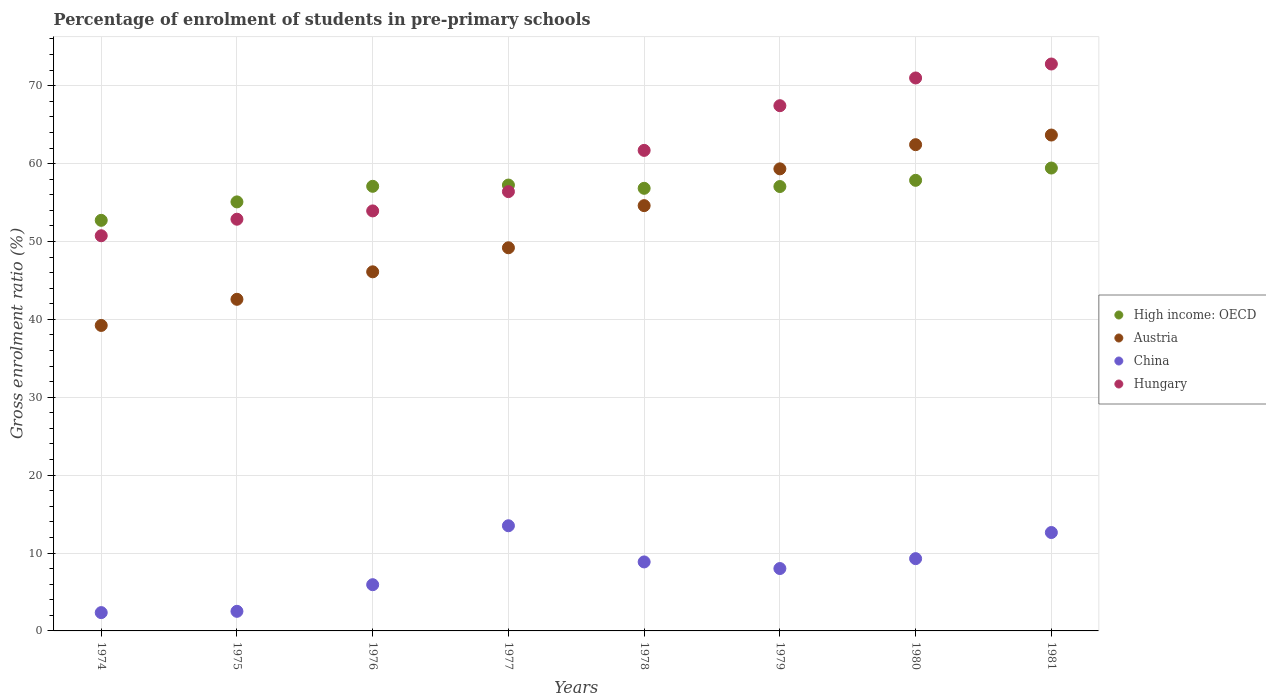How many different coloured dotlines are there?
Give a very brief answer. 4. What is the percentage of students enrolled in pre-primary schools in High income: OECD in 1974?
Offer a terse response. 52.72. Across all years, what is the maximum percentage of students enrolled in pre-primary schools in China?
Your response must be concise. 13.5. Across all years, what is the minimum percentage of students enrolled in pre-primary schools in China?
Keep it short and to the point. 2.35. In which year was the percentage of students enrolled in pre-primary schools in High income: OECD minimum?
Your response must be concise. 1974. What is the total percentage of students enrolled in pre-primary schools in High income: OECD in the graph?
Your answer should be compact. 453.31. What is the difference between the percentage of students enrolled in pre-primary schools in High income: OECD in 1977 and that in 1980?
Ensure brevity in your answer.  -0.61. What is the difference between the percentage of students enrolled in pre-primary schools in High income: OECD in 1976 and the percentage of students enrolled in pre-primary schools in Austria in 1974?
Provide a short and direct response. 17.86. What is the average percentage of students enrolled in pre-primary schools in Austria per year?
Offer a very short reply. 52.14. In the year 1978, what is the difference between the percentage of students enrolled in pre-primary schools in Hungary and percentage of students enrolled in pre-primary schools in High income: OECD?
Ensure brevity in your answer.  4.87. In how many years, is the percentage of students enrolled in pre-primary schools in Hungary greater than 26 %?
Provide a succinct answer. 8. What is the ratio of the percentage of students enrolled in pre-primary schools in Austria in 1976 to that in 1980?
Your answer should be very brief. 0.74. Is the percentage of students enrolled in pre-primary schools in Hungary in 1975 less than that in 1980?
Your answer should be compact. Yes. Is the difference between the percentage of students enrolled in pre-primary schools in Hungary in 1980 and 1981 greater than the difference between the percentage of students enrolled in pre-primary schools in High income: OECD in 1980 and 1981?
Your answer should be very brief. No. What is the difference between the highest and the second highest percentage of students enrolled in pre-primary schools in Austria?
Your answer should be very brief. 1.24. What is the difference between the highest and the lowest percentage of students enrolled in pre-primary schools in China?
Provide a short and direct response. 11.15. In how many years, is the percentage of students enrolled in pre-primary schools in Hungary greater than the average percentage of students enrolled in pre-primary schools in Hungary taken over all years?
Offer a terse response. 4. Does the percentage of students enrolled in pre-primary schools in China monotonically increase over the years?
Your answer should be very brief. No. Is the percentage of students enrolled in pre-primary schools in High income: OECD strictly greater than the percentage of students enrolled in pre-primary schools in Hungary over the years?
Provide a short and direct response. No. Is the percentage of students enrolled in pre-primary schools in China strictly less than the percentage of students enrolled in pre-primary schools in High income: OECD over the years?
Provide a short and direct response. Yes. How many years are there in the graph?
Provide a short and direct response. 8. Are the values on the major ticks of Y-axis written in scientific E-notation?
Make the answer very short. No. Does the graph contain grids?
Provide a short and direct response. Yes. What is the title of the graph?
Your answer should be compact. Percentage of enrolment of students in pre-primary schools. What is the Gross enrolment ratio (%) of High income: OECD in 1974?
Your answer should be compact. 52.72. What is the Gross enrolment ratio (%) in Austria in 1974?
Offer a terse response. 39.22. What is the Gross enrolment ratio (%) of China in 1974?
Keep it short and to the point. 2.35. What is the Gross enrolment ratio (%) in Hungary in 1974?
Offer a very short reply. 50.74. What is the Gross enrolment ratio (%) in High income: OECD in 1975?
Your response must be concise. 55.08. What is the Gross enrolment ratio (%) of Austria in 1975?
Your answer should be compact. 42.58. What is the Gross enrolment ratio (%) in China in 1975?
Ensure brevity in your answer.  2.52. What is the Gross enrolment ratio (%) of Hungary in 1975?
Give a very brief answer. 52.86. What is the Gross enrolment ratio (%) of High income: OECD in 1976?
Your response must be concise. 57.09. What is the Gross enrolment ratio (%) of Austria in 1976?
Offer a very short reply. 46.11. What is the Gross enrolment ratio (%) of China in 1976?
Your answer should be compact. 5.93. What is the Gross enrolment ratio (%) of Hungary in 1976?
Your response must be concise. 53.93. What is the Gross enrolment ratio (%) of High income: OECD in 1977?
Provide a succinct answer. 57.25. What is the Gross enrolment ratio (%) in Austria in 1977?
Your answer should be compact. 49.19. What is the Gross enrolment ratio (%) in China in 1977?
Provide a short and direct response. 13.5. What is the Gross enrolment ratio (%) in Hungary in 1977?
Keep it short and to the point. 56.4. What is the Gross enrolment ratio (%) in High income: OECD in 1978?
Give a very brief answer. 56.83. What is the Gross enrolment ratio (%) in Austria in 1978?
Provide a short and direct response. 54.6. What is the Gross enrolment ratio (%) in China in 1978?
Offer a terse response. 8.86. What is the Gross enrolment ratio (%) of Hungary in 1978?
Provide a succinct answer. 61.7. What is the Gross enrolment ratio (%) in High income: OECD in 1979?
Keep it short and to the point. 57.06. What is the Gross enrolment ratio (%) of Austria in 1979?
Provide a succinct answer. 59.33. What is the Gross enrolment ratio (%) in China in 1979?
Ensure brevity in your answer.  8.01. What is the Gross enrolment ratio (%) in Hungary in 1979?
Provide a succinct answer. 67.44. What is the Gross enrolment ratio (%) in High income: OECD in 1980?
Give a very brief answer. 57.85. What is the Gross enrolment ratio (%) in Austria in 1980?
Keep it short and to the point. 62.43. What is the Gross enrolment ratio (%) in China in 1980?
Offer a terse response. 9.28. What is the Gross enrolment ratio (%) of Hungary in 1980?
Provide a short and direct response. 71. What is the Gross enrolment ratio (%) in High income: OECD in 1981?
Offer a very short reply. 59.43. What is the Gross enrolment ratio (%) in Austria in 1981?
Provide a succinct answer. 63.67. What is the Gross enrolment ratio (%) in China in 1981?
Give a very brief answer. 12.63. What is the Gross enrolment ratio (%) in Hungary in 1981?
Offer a terse response. 72.79. Across all years, what is the maximum Gross enrolment ratio (%) in High income: OECD?
Keep it short and to the point. 59.43. Across all years, what is the maximum Gross enrolment ratio (%) of Austria?
Offer a terse response. 63.67. Across all years, what is the maximum Gross enrolment ratio (%) of China?
Ensure brevity in your answer.  13.5. Across all years, what is the maximum Gross enrolment ratio (%) of Hungary?
Ensure brevity in your answer.  72.79. Across all years, what is the minimum Gross enrolment ratio (%) of High income: OECD?
Your answer should be very brief. 52.72. Across all years, what is the minimum Gross enrolment ratio (%) of Austria?
Keep it short and to the point. 39.22. Across all years, what is the minimum Gross enrolment ratio (%) of China?
Offer a very short reply. 2.35. Across all years, what is the minimum Gross enrolment ratio (%) of Hungary?
Your response must be concise. 50.74. What is the total Gross enrolment ratio (%) of High income: OECD in the graph?
Give a very brief answer. 453.31. What is the total Gross enrolment ratio (%) in Austria in the graph?
Offer a very short reply. 417.13. What is the total Gross enrolment ratio (%) in China in the graph?
Keep it short and to the point. 63.09. What is the total Gross enrolment ratio (%) of Hungary in the graph?
Give a very brief answer. 486.85. What is the difference between the Gross enrolment ratio (%) in High income: OECD in 1974 and that in 1975?
Your answer should be very brief. -2.37. What is the difference between the Gross enrolment ratio (%) of Austria in 1974 and that in 1975?
Your response must be concise. -3.36. What is the difference between the Gross enrolment ratio (%) in China in 1974 and that in 1975?
Your answer should be very brief. -0.17. What is the difference between the Gross enrolment ratio (%) in Hungary in 1974 and that in 1975?
Give a very brief answer. -2.12. What is the difference between the Gross enrolment ratio (%) of High income: OECD in 1974 and that in 1976?
Your response must be concise. -4.37. What is the difference between the Gross enrolment ratio (%) in Austria in 1974 and that in 1976?
Your response must be concise. -6.88. What is the difference between the Gross enrolment ratio (%) of China in 1974 and that in 1976?
Offer a terse response. -3.58. What is the difference between the Gross enrolment ratio (%) in Hungary in 1974 and that in 1976?
Your answer should be compact. -3.19. What is the difference between the Gross enrolment ratio (%) in High income: OECD in 1974 and that in 1977?
Make the answer very short. -4.53. What is the difference between the Gross enrolment ratio (%) of Austria in 1974 and that in 1977?
Your answer should be compact. -9.97. What is the difference between the Gross enrolment ratio (%) in China in 1974 and that in 1977?
Keep it short and to the point. -11.15. What is the difference between the Gross enrolment ratio (%) of Hungary in 1974 and that in 1977?
Offer a very short reply. -5.67. What is the difference between the Gross enrolment ratio (%) in High income: OECD in 1974 and that in 1978?
Your answer should be very brief. -4.11. What is the difference between the Gross enrolment ratio (%) of Austria in 1974 and that in 1978?
Your response must be concise. -15.38. What is the difference between the Gross enrolment ratio (%) in China in 1974 and that in 1978?
Keep it short and to the point. -6.51. What is the difference between the Gross enrolment ratio (%) of Hungary in 1974 and that in 1978?
Ensure brevity in your answer.  -10.96. What is the difference between the Gross enrolment ratio (%) in High income: OECD in 1974 and that in 1979?
Provide a short and direct response. -4.34. What is the difference between the Gross enrolment ratio (%) of Austria in 1974 and that in 1979?
Offer a terse response. -20.1. What is the difference between the Gross enrolment ratio (%) in China in 1974 and that in 1979?
Give a very brief answer. -5.66. What is the difference between the Gross enrolment ratio (%) in Hungary in 1974 and that in 1979?
Provide a short and direct response. -16.7. What is the difference between the Gross enrolment ratio (%) of High income: OECD in 1974 and that in 1980?
Offer a very short reply. -5.14. What is the difference between the Gross enrolment ratio (%) of Austria in 1974 and that in 1980?
Your answer should be compact. -23.21. What is the difference between the Gross enrolment ratio (%) of China in 1974 and that in 1980?
Offer a very short reply. -6.93. What is the difference between the Gross enrolment ratio (%) in Hungary in 1974 and that in 1980?
Provide a succinct answer. -20.26. What is the difference between the Gross enrolment ratio (%) in High income: OECD in 1974 and that in 1981?
Offer a very short reply. -6.72. What is the difference between the Gross enrolment ratio (%) in Austria in 1974 and that in 1981?
Your response must be concise. -24.45. What is the difference between the Gross enrolment ratio (%) of China in 1974 and that in 1981?
Offer a terse response. -10.28. What is the difference between the Gross enrolment ratio (%) in Hungary in 1974 and that in 1981?
Give a very brief answer. -22.05. What is the difference between the Gross enrolment ratio (%) in High income: OECD in 1975 and that in 1976?
Ensure brevity in your answer.  -2. What is the difference between the Gross enrolment ratio (%) in Austria in 1975 and that in 1976?
Give a very brief answer. -3.53. What is the difference between the Gross enrolment ratio (%) in China in 1975 and that in 1976?
Provide a succinct answer. -3.42. What is the difference between the Gross enrolment ratio (%) of Hungary in 1975 and that in 1976?
Give a very brief answer. -1.06. What is the difference between the Gross enrolment ratio (%) of High income: OECD in 1975 and that in 1977?
Make the answer very short. -2.16. What is the difference between the Gross enrolment ratio (%) in Austria in 1975 and that in 1977?
Your answer should be compact. -6.62. What is the difference between the Gross enrolment ratio (%) of China in 1975 and that in 1977?
Keep it short and to the point. -10.99. What is the difference between the Gross enrolment ratio (%) in Hungary in 1975 and that in 1977?
Provide a short and direct response. -3.54. What is the difference between the Gross enrolment ratio (%) in High income: OECD in 1975 and that in 1978?
Your response must be concise. -1.74. What is the difference between the Gross enrolment ratio (%) of Austria in 1975 and that in 1978?
Give a very brief answer. -12.03. What is the difference between the Gross enrolment ratio (%) of China in 1975 and that in 1978?
Offer a very short reply. -6.34. What is the difference between the Gross enrolment ratio (%) in Hungary in 1975 and that in 1978?
Offer a terse response. -8.84. What is the difference between the Gross enrolment ratio (%) of High income: OECD in 1975 and that in 1979?
Offer a terse response. -1.97. What is the difference between the Gross enrolment ratio (%) of Austria in 1975 and that in 1979?
Provide a short and direct response. -16.75. What is the difference between the Gross enrolment ratio (%) in China in 1975 and that in 1979?
Keep it short and to the point. -5.49. What is the difference between the Gross enrolment ratio (%) of Hungary in 1975 and that in 1979?
Ensure brevity in your answer.  -14.57. What is the difference between the Gross enrolment ratio (%) in High income: OECD in 1975 and that in 1980?
Offer a terse response. -2.77. What is the difference between the Gross enrolment ratio (%) of Austria in 1975 and that in 1980?
Give a very brief answer. -19.85. What is the difference between the Gross enrolment ratio (%) in China in 1975 and that in 1980?
Make the answer very short. -6.76. What is the difference between the Gross enrolment ratio (%) in Hungary in 1975 and that in 1980?
Offer a terse response. -18.13. What is the difference between the Gross enrolment ratio (%) in High income: OECD in 1975 and that in 1981?
Offer a terse response. -4.35. What is the difference between the Gross enrolment ratio (%) of Austria in 1975 and that in 1981?
Ensure brevity in your answer.  -21.09. What is the difference between the Gross enrolment ratio (%) of China in 1975 and that in 1981?
Give a very brief answer. -10.12. What is the difference between the Gross enrolment ratio (%) in Hungary in 1975 and that in 1981?
Your answer should be compact. -19.93. What is the difference between the Gross enrolment ratio (%) of High income: OECD in 1976 and that in 1977?
Give a very brief answer. -0.16. What is the difference between the Gross enrolment ratio (%) of Austria in 1976 and that in 1977?
Your answer should be compact. -3.09. What is the difference between the Gross enrolment ratio (%) in China in 1976 and that in 1977?
Offer a very short reply. -7.57. What is the difference between the Gross enrolment ratio (%) in Hungary in 1976 and that in 1977?
Your answer should be very brief. -2.48. What is the difference between the Gross enrolment ratio (%) in High income: OECD in 1976 and that in 1978?
Provide a short and direct response. 0.26. What is the difference between the Gross enrolment ratio (%) in Austria in 1976 and that in 1978?
Ensure brevity in your answer.  -8.5. What is the difference between the Gross enrolment ratio (%) in China in 1976 and that in 1978?
Your answer should be very brief. -2.92. What is the difference between the Gross enrolment ratio (%) of Hungary in 1976 and that in 1978?
Make the answer very short. -7.77. What is the difference between the Gross enrolment ratio (%) of High income: OECD in 1976 and that in 1979?
Your response must be concise. 0.03. What is the difference between the Gross enrolment ratio (%) of Austria in 1976 and that in 1979?
Offer a very short reply. -13.22. What is the difference between the Gross enrolment ratio (%) of China in 1976 and that in 1979?
Offer a very short reply. -2.08. What is the difference between the Gross enrolment ratio (%) in Hungary in 1976 and that in 1979?
Offer a terse response. -13.51. What is the difference between the Gross enrolment ratio (%) in High income: OECD in 1976 and that in 1980?
Your response must be concise. -0.77. What is the difference between the Gross enrolment ratio (%) in Austria in 1976 and that in 1980?
Provide a short and direct response. -16.32. What is the difference between the Gross enrolment ratio (%) in China in 1976 and that in 1980?
Keep it short and to the point. -3.35. What is the difference between the Gross enrolment ratio (%) of Hungary in 1976 and that in 1980?
Provide a short and direct response. -17.07. What is the difference between the Gross enrolment ratio (%) in High income: OECD in 1976 and that in 1981?
Keep it short and to the point. -2.35. What is the difference between the Gross enrolment ratio (%) of Austria in 1976 and that in 1981?
Offer a terse response. -17.56. What is the difference between the Gross enrolment ratio (%) of Hungary in 1976 and that in 1981?
Make the answer very short. -18.86. What is the difference between the Gross enrolment ratio (%) in High income: OECD in 1977 and that in 1978?
Provide a short and direct response. 0.42. What is the difference between the Gross enrolment ratio (%) of Austria in 1977 and that in 1978?
Provide a succinct answer. -5.41. What is the difference between the Gross enrolment ratio (%) of China in 1977 and that in 1978?
Keep it short and to the point. 4.64. What is the difference between the Gross enrolment ratio (%) of Hungary in 1977 and that in 1978?
Offer a terse response. -5.29. What is the difference between the Gross enrolment ratio (%) in High income: OECD in 1977 and that in 1979?
Your answer should be very brief. 0.19. What is the difference between the Gross enrolment ratio (%) in Austria in 1977 and that in 1979?
Give a very brief answer. -10.13. What is the difference between the Gross enrolment ratio (%) of China in 1977 and that in 1979?
Offer a very short reply. 5.49. What is the difference between the Gross enrolment ratio (%) in Hungary in 1977 and that in 1979?
Offer a very short reply. -11.03. What is the difference between the Gross enrolment ratio (%) of High income: OECD in 1977 and that in 1980?
Keep it short and to the point. -0.61. What is the difference between the Gross enrolment ratio (%) in Austria in 1977 and that in 1980?
Provide a short and direct response. -13.24. What is the difference between the Gross enrolment ratio (%) in China in 1977 and that in 1980?
Provide a short and direct response. 4.22. What is the difference between the Gross enrolment ratio (%) of Hungary in 1977 and that in 1980?
Make the answer very short. -14.59. What is the difference between the Gross enrolment ratio (%) of High income: OECD in 1977 and that in 1981?
Ensure brevity in your answer.  -2.19. What is the difference between the Gross enrolment ratio (%) of Austria in 1977 and that in 1981?
Offer a terse response. -14.47. What is the difference between the Gross enrolment ratio (%) of China in 1977 and that in 1981?
Provide a succinct answer. 0.87. What is the difference between the Gross enrolment ratio (%) in Hungary in 1977 and that in 1981?
Give a very brief answer. -16.38. What is the difference between the Gross enrolment ratio (%) of High income: OECD in 1978 and that in 1979?
Make the answer very short. -0.23. What is the difference between the Gross enrolment ratio (%) in Austria in 1978 and that in 1979?
Make the answer very short. -4.72. What is the difference between the Gross enrolment ratio (%) of China in 1978 and that in 1979?
Provide a short and direct response. 0.85. What is the difference between the Gross enrolment ratio (%) in Hungary in 1978 and that in 1979?
Provide a short and direct response. -5.74. What is the difference between the Gross enrolment ratio (%) in High income: OECD in 1978 and that in 1980?
Your answer should be compact. -1.03. What is the difference between the Gross enrolment ratio (%) in Austria in 1978 and that in 1980?
Provide a succinct answer. -7.83. What is the difference between the Gross enrolment ratio (%) of China in 1978 and that in 1980?
Provide a short and direct response. -0.42. What is the difference between the Gross enrolment ratio (%) in Hungary in 1978 and that in 1980?
Provide a succinct answer. -9.3. What is the difference between the Gross enrolment ratio (%) of High income: OECD in 1978 and that in 1981?
Your answer should be very brief. -2.6. What is the difference between the Gross enrolment ratio (%) in Austria in 1978 and that in 1981?
Make the answer very short. -9.06. What is the difference between the Gross enrolment ratio (%) of China in 1978 and that in 1981?
Make the answer very short. -3.78. What is the difference between the Gross enrolment ratio (%) of Hungary in 1978 and that in 1981?
Ensure brevity in your answer.  -11.09. What is the difference between the Gross enrolment ratio (%) of High income: OECD in 1979 and that in 1980?
Offer a very short reply. -0.8. What is the difference between the Gross enrolment ratio (%) in Austria in 1979 and that in 1980?
Your answer should be very brief. -3.1. What is the difference between the Gross enrolment ratio (%) in China in 1979 and that in 1980?
Offer a very short reply. -1.27. What is the difference between the Gross enrolment ratio (%) of Hungary in 1979 and that in 1980?
Make the answer very short. -3.56. What is the difference between the Gross enrolment ratio (%) of High income: OECD in 1979 and that in 1981?
Provide a succinct answer. -2.37. What is the difference between the Gross enrolment ratio (%) in Austria in 1979 and that in 1981?
Your answer should be very brief. -4.34. What is the difference between the Gross enrolment ratio (%) of China in 1979 and that in 1981?
Make the answer very short. -4.62. What is the difference between the Gross enrolment ratio (%) of Hungary in 1979 and that in 1981?
Your answer should be compact. -5.35. What is the difference between the Gross enrolment ratio (%) in High income: OECD in 1980 and that in 1981?
Keep it short and to the point. -1.58. What is the difference between the Gross enrolment ratio (%) in Austria in 1980 and that in 1981?
Your response must be concise. -1.24. What is the difference between the Gross enrolment ratio (%) in China in 1980 and that in 1981?
Offer a very short reply. -3.35. What is the difference between the Gross enrolment ratio (%) in Hungary in 1980 and that in 1981?
Make the answer very short. -1.79. What is the difference between the Gross enrolment ratio (%) in High income: OECD in 1974 and the Gross enrolment ratio (%) in Austria in 1975?
Offer a very short reply. 10.14. What is the difference between the Gross enrolment ratio (%) in High income: OECD in 1974 and the Gross enrolment ratio (%) in China in 1975?
Your answer should be compact. 50.2. What is the difference between the Gross enrolment ratio (%) of High income: OECD in 1974 and the Gross enrolment ratio (%) of Hungary in 1975?
Ensure brevity in your answer.  -0.14. What is the difference between the Gross enrolment ratio (%) in Austria in 1974 and the Gross enrolment ratio (%) in China in 1975?
Your response must be concise. 36.71. What is the difference between the Gross enrolment ratio (%) in Austria in 1974 and the Gross enrolment ratio (%) in Hungary in 1975?
Give a very brief answer. -13.64. What is the difference between the Gross enrolment ratio (%) in China in 1974 and the Gross enrolment ratio (%) in Hungary in 1975?
Provide a succinct answer. -50.51. What is the difference between the Gross enrolment ratio (%) of High income: OECD in 1974 and the Gross enrolment ratio (%) of Austria in 1976?
Make the answer very short. 6.61. What is the difference between the Gross enrolment ratio (%) of High income: OECD in 1974 and the Gross enrolment ratio (%) of China in 1976?
Ensure brevity in your answer.  46.78. What is the difference between the Gross enrolment ratio (%) in High income: OECD in 1974 and the Gross enrolment ratio (%) in Hungary in 1976?
Offer a very short reply. -1.21. What is the difference between the Gross enrolment ratio (%) in Austria in 1974 and the Gross enrolment ratio (%) in China in 1976?
Your answer should be very brief. 33.29. What is the difference between the Gross enrolment ratio (%) in Austria in 1974 and the Gross enrolment ratio (%) in Hungary in 1976?
Make the answer very short. -14.7. What is the difference between the Gross enrolment ratio (%) in China in 1974 and the Gross enrolment ratio (%) in Hungary in 1976?
Your response must be concise. -51.57. What is the difference between the Gross enrolment ratio (%) of High income: OECD in 1974 and the Gross enrolment ratio (%) of Austria in 1977?
Provide a succinct answer. 3.52. What is the difference between the Gross enrolment ratio (%) of High income: OECD in 1974 and the Gross enrolment ratio (%) of China in 1977?
Your answer should be very brief. 39.21. What is the difference between the Gross enrolment ratio (%) in High income: OECD in 1974 and the Gross enrolment ratio (%) in Hungary in 1977?
Ensure brevity in your answer.  -3.69. What is the difference between the Gross enrolment ratio (%) of Austria in 1974 and the Gross enrolment ratio (%) of China in 1977?
Your answer should be compact. 25.72. What is the difference between the Gross enrolment ratio (%) of Austria in 1974 and the Gross enrolment ratio (%) of Hungary in 1977?
Give a very brief answer. -17.18. What is the difference between the Gross enrolment ratio (%) in China in 1974 and the Gross enrolment ratio (%) in Hungary in 1977?
Provide a succinct answer. -54.05. What is the difference between the Gross enrolment ratio (%) in High income: OECD in 1974 and the Gross enrolment ratio (%) in Austria in 1978?
Keep it short and to the point. -1.89. What is the difference between the Gross enrolment ratio (%) of High income: OECD in 1974 and the Gross enrolment ratio (%) of China in 1978?
Your response must be concise. 43.86. What is the difference between the Gross enrolment ratio (%) in High income: OECD in 1974 and the Gross enrolment ratio (%) in Hungary in 1978?
Provide a succinct answer. -8.98. What is the difference between the Gross enrolment ratio (%) of Austria in 1974 and the Gross enrolment ratio (%) of China in 1978?
Offer a very short reply. 30.36. What is the difference between the Gross enrolment ratio (%) in Austria in 1974 and the Gross enrolment ratio (%) in Hungary in 1978?
Provide a short and direct response. -22.48. What is the difference between the Gross enrolment ratio (%) in China in 1974 and the Gross enrolment ratio (%) in Hungary in 1978?
Ensure brevity in your answer.  -59.35. What is the difference between the Gross enrolment ratio (%) of High income: OECD in 1974 and the Gross enrolment ratio (%) of Austria in 1979?
Offer a terse response. -6.61. What is the difference between the Gross enrolment ratio (%) in High income: OECD in 1974 and the Gross enrolment ratio (%) in China in 1979?
Make the answer very short. 44.71. What is the difference between the Gross enrolment ratio (%) of High income: OECD in 1974 and the Gross enrolment ratio (%) of Hungary in 1979?
Provide a succinct answer. -14.72. What is the difference between the Gross enrolment ratio (%) of Austria in 1974 and the Gross enrolment ratio (%) of China in 1979?
Provide a short and direct response. 31.21. What is the difference between the Gross enrolment ratio (%) of Austria in 1974 and the Gross enrolment ratio (%) of Hungary in 1979?
Make the answer very short. -28.21. What is the difference between the Gross enrolment ratio (%) of China in 1974 and the Gross enrolment ratio (%) of Hungary in 1979?
Provide a short and direct response. -65.08. What is the difference between the Gross enrolment ratio (%) in High income: OECD in 1974 and the Gross enrolment ratio (%) in Austria in 1980?
Ensure brevity in your answer.  -9.71. What is the difference between the Gross enrolment ratio (%) of High income: OECD in 1974 and the Gross enrolment ratio (%) of China in 1980?
Give a very brief answer. 43.44. What is the difference between the Gross enrolment ratio (%) of High income: OECD in 1974 and the Gross enrolment ratio (%) of Hungary in 1980?
Your response must be concise. -18.28. What is the difference between the Gross enrolment ratio (%) in Austria in 1974 and the Gross enrolment ratio (%) in China in 1980?
Provide a short and direct response. 29.94. What is the difference between the Gross enrolment ratio (%) of Austria in 1974 and the Gross enrolment ratio (%) of Hungary in 1980?
Provide a succinct answer. -31.77. What is the difference between the Gross enrolment ratio (%) of China in 1974 and the Gross enrolment ratio (%) of Hungary in 1980?
Provide a short and direct response. -68.64. What is the difference between the Gross enrolment ratio (%) of High income: OECD in 1974 and the Gross enrolment ratio (%) of Austria in 1981?
Your response must be concise. -10.95. What is the difference between the Gross enrolment ratio (%) in High income: OECD in 1974 and the Gross enrolment ratio (%) in China in 1981?
Give a very brief answer. 40.08. What is the difference between the Gross enrolment ratio (%) in High income: OECD in 1974 and the Gross enrolment ratio (%) in Hungary in 1981?
Offer a very short reply. -20.07. What is the difference between the Gross enrolment ratio (%) of Austria in 1974 and the Gross enrolment ratio (%) of China in 1981?
Make the answer very short. 26.59. What is the difference between the Gross enrolment ratio (%) in Austria in 1974 and the Gross enrolment ratio (%) in Hungary in 1981?
Ensure brevity in your answer.  -33.57. What is the difference between the Gross enrolment ratio (%) in China in 1974 and the Gross enrolment ratio (%) in Hungary in 1981?
Make the answer very short. -70.44. What is the difference between the Gross enrolment ratio (%) of High income: OECD in 1975 and the Gross enrolment ratio (%) of Austria in 1976?
Give a very brief answer. 8.98. What is the difference between the Gross enrolment ratio (%) of High income: OECD in 1975 and the Gross enrolment ratio (%) of China in 1976?
Your answer should be compact. 49.15. What is the difference between the Gross enrolment ratio (%) in High income: OECD in 1975 and the Gross enrolment ratio (%) in Hungary in 1976?
Offer a very short reply. 1.16. What is the difference between the Gross enrolment ratio (%) of Austria in 1975 and the Gross enrolment ratio (%) of China in 1976?
Your answer should be very brief. 36.64. What is the difference between the Gross enrolment ratio (%) in Austria in 1975 and the Gross enrolment ratio (%) in Hungary in 1976?
Give a very brief answer. -11.35. What is the difference between the Gross enrolment ratio (%) in China in 1975 and the Gross enrolment ratio (%) in Hungary in 1976?
Offer a terse response. -51.41. What is the difference between the Gross enrolment ratio (%) in High income: OECD in 1975 and the Gross enrolment ratio (%) in Austria in 1977?
Offer a terse response. 5.89. What is the difference between the Gross enrolment ratio (%) of High income: OECD in 1975 and the Gross enrolment ratio (%) of China in 1977?
Your answer should be compact. 41.58. What is the difference between the Gross enrolment ratio (%) in High income: OECD in 1975 and the Gross enrolment ratio (%) in Hungary in 1977?
Make the answer very short. -1.32. What is the difference between the Gross enrolment ratio (%) in Austria in 1975 and the Gross enrolment ratio (%) in China in 1977?
Your answer should be very brief. 29.07. What is the difference between the Gross enrolment ratio (%) of Austria in 1975 and the Gross enrolment ratio (%) of Hungary in 1977?
Your response must be concise. -13.83. What is the difference between the Gross enrolment ratio (%) of China in 1975 and the Gross enrolment ratio (%) of Hungary in 1977?
Provide a short and direct response. -53.89. What is the difference between the Gross enrolment ratio (%) in High income: OECD in 1975 and the Gross enrolment ratio (%) in Austria in 1978?
Provide a succinct answer. 0.48. What is the difference between the Gross enrolment ratio (%) in High income: OECD in 1975 and the Gross enrolment ratio (%) in China in 1978?
Offer a very short reply. 46.23. What is the difference between the Gross enrolment ratio (%) in High income: OECD in 1975 and the Gross enrolment ratio (%) in Hungary in 1978?
Give a very brief answer. -6.61. What is the difference between the Gross enrolment ratio (%) of Austria in 1975 and the Gross enrolment ratio (%) of China in 1978?
Make the answer very short. 33.72. What is the difference between the Gross enrolment ratio (%) in Austria in 1975 and the Gross enrolment ratio (%) in Hungary in 1978?
Your response must be concise. -19.12. What is the difference between the Gross enrolment ratio (%) in China in 1975 and the Gross enrolment ratio (%) in Hungary in 1978?
Provide a succinct answer. -59.18. What is the difference between the Gross enrolment ratio (%) in High income: OECD in 1975 and the Gross enrolment ratio (%) in Austria in 1979?
Ensure brevity in your answer.  -4.24. What is the difference between the Gross enrolment ratio (%) of High income: OECD in 1975 and the Gross enrolment ratio (%) of China in 1979?
Make the answer very short. 47.07. What is the difference between the Gross enrolment ratio (%) of High income: OECD in 1975 and the Gross enrolment ratio (%) of Hungary in 1979?
Offer a very short reply. -12.35. What is the difference between the Gross enrolment ratio (%) in Austria in 1975 and the Gross enrolment ratio (%) in China in 1979?
Offer a terse response. 34.57. What is the difference between the Gross enrolment ratio (%) of Austria in 1975 and the Gross enrolment ratio (%) of Hungary in 1979?
Make the answer very short. -24.86. What is the difference between the Gross enrolment ratio (%) in China in 1975 and the Gross enrolment ratio (%) in Hungary in 1979?
Your response must be concise. -64.92. What is the difference between the Gross enrolment ratio (%) in High income: OECD in 1975 and the Gross enrolment ratio (%) in Austria in 1980?
Ensure brevity in your answer.  -7.35. What is the difference between the Gross enrolment ratio (%) of High income: OECD in 1975 and the Gross enrolment ratio (%) of China in 1980?
Offer a terse response. 45.8. What is the difference between the Gross enrolment ratio (%) of High income: OECD in 1975 and the Gross enrolment ratio (%) of Hungary in 1980?
Offer a terse response. -15.91. What is the difference between the Gross enrolment ratio (%) of Austria in 1975 and the Gross enrolment ratio (%) of China in 1980?
Offer a very short reply. 33.3. What is the difference between the Gross enrolment ratio (%) in Austria in 1975 and the Gross enrolment ratio (%) in Hungary in 1980?
Keep it short and to the point. -28.42. What is the difference between the Gross enrolment ratio (%) in China in 1975 and the Gross enrolment ratio (%) in Hungary in 1980?
Your answer should be compact. -68.48. What is the difference between the Gross enrolment ratio (%) of High income: OECD in 1975 and the Gross enrolment ratio (%) of Austria in 1981?
Provide a succinct answer. -8.58. What is the difference between the Gross enrolment ratio (%) of High income: OECD in 1975 and the Gross enrolment ratio (%) of China in 1981?
Your answer should be compact. 42.45. What is the difference between the Gross enrolment ratio (%) in High income: OECD in 1975 and the Gross enrolment ratio (%) in Hungary in 1981?
Make the answer very short. -17.7. What is the difference between the Gross enrolment ratio (%) in Austria in 1975 and the Gross enrolment ratio (%) in China in 1981?
Offer a very short reply. 29.94. What is the difference between the Gross enrolment ratio (%) of Austria in 1975 and the Gross enrolment ratio (%) of Hungary in 1981?
Provide a short and direct response. -30.21. What is the difference between the Gross enrolment ratio (%) of China in 1975 and the Gross enrolment ratio (%) of Hungary in 1981?
Your response must be concise. -70.27. What is the difference between the Gross enrolment ratio (%) of High income: OECD in 1976 and the Gross enrolment ratio (%) of Austria in 1977?
Make the answer very short. 7.89. What is the difference between the Gross enrolment ratio (%) of High income: OECD in 1976 and the Gross enrolment ratio (%) of China in 1977?
Provide a succinct answer. 43.58. What is the difference between the Gross enrolment ratio (%) of High income: OECD in 1976 and the Gross enrolment ratio (%) of Hungary in 1977?
Your response must be concise. 0.68. What is the difference between the Gross enrolment ratio (%) in Austria in 1976 and the Gross enrolment ratio (%) in China in 1977?
Your response must be concise. 32.6. What is the difference between the Gross enrolment ratio (%) of Austria in 1976 and the Gross enrolment ratio (%) of Hungary in 1977?
Make the answer very short. -10.3. What is the difference between the Gross enrolment ratio (%) in China in 1976 and the Gross enrolment ratio (%) in Hungary in 1977?
Your answer should be compact. -50.47. What is the difference between the Gross enrolment ratio (%) in High income: OECD in 1976 and the Gross enrolment ratio (%) in Austria in 1978?
Your answer should be very brief. 2.48. What is the difference between the Gross enrolment ratio (%) of High income: OECD in 1976 and the Gross enrolment ratio (%) of China in 1978?
Offer a very short reply. 48.23. What is the difference between the Gross enrolment ratio (%) of High income: OECD in 1976 and the Gross enrolment ratio (%) of Hungary in 1978?
Provide a succinct answer. -4.61. What is the difference between the Gross enrolment ratio (%) of Austria in 1976 and the Gross enrolment ratio (%) of China in 1978?
Keep it short and to the point. 37.25. What is the difference between the Gross enrolment ratio (%) of Austria in 1976 and the Gross enrolment ratio (%) of Hungary in 1978?
Your response must be concise. -15.59. What is the difference between the Gross enrolment ratio (%) in China in 1976 and the Gross enrolment ratio (%) in Hungary in 1978?
Offer a very short reply. -55.76. What is the difference between the Gross enrolment ratio (%) in High income: OECD in 1976 and the Gross enrolment ratio (%) in Austria in 1979?
Make the answer very short. -2.24. What is the difference between the Gross enrolment ratio (%) in High income: OECD in 1976 and the Gross enrolment ratio (%) in China in 1979?
Give a very brief answer. 49.08. What is the difference between the Gross enrolment ratio (%) in High income: OECD in 1976 and the Gross enrolment ratio (%) in Hungary in 1979?
Your answer should be compact. -10.35. What is the difference between the Gross enrolment ratio (%) of Austria in 1976 and the Gross enrolment ratio (%) of China in 1979?
Offer a terse response. 38.1. What is the difference between the Gross enrolment ratio (%) of Austria in 1976 and the Gross enrolment ratio (%) of Hungary in 1979?
Provide a succinct answer. -21.33. What is the difference between the Gross enrolment ratio (%) of China in 1976 and the Gross enrolment ratio (%) of Hungary in 1979?
Give a very brief answer. -61.5. What is the difference between the Gross enrolment ratio (%) of High income: OECD in 1976 and the Gross enrolment ratio (%) of Austria in 1980?
Make the answer very short. -5.34. What is the difference between the Gross enrolment ratio (%) in High income: OECD in 1976 and the Gross enrolment ratio (%) in China in 1980?
Provide a succinct answer. 47.81. What is the difference between the Gross enrolment ratio (%) of High income: OECD in 1976 and the Gross enrolment ratio (%) of Hungary in 1980?
Ensure brevity in your answer.  -13.91. What is the difference between the Gross enrolment ratio (%) in Austria in 1976 and the Gross enrolment ratio (%) in China in 1980?
Your answer should be very brief. 36.83. What is the difference between the Gross enrolment ratio (%) in Austria in 1976 and the Gross enrolment ratio (%) in Hungary in 1980?
Your response must be concise. -24.89. What is the difference between the Gross enrolment ratio (%) in China in 1976 and the Gross enrolment ratio (%) in Hungary in 1980?
Keep it short and to the point. -65.06. What is the difference between the Gross enrolment ratio (%) in High income: OECD in 1976 and the Gross enrolment ratio (%) in Austria in 1981?
Provide a succinct answer. -6.58. What is the difference between the Gross enrolment ratio (%) of High income: OECD in 1976 and the Gross enrolment ratio (%) of China in 1981?
Offer a very short reply. 44.45. What is the difference between the Gross enrolment ratio (%) in High income: OECD in 1976 and the Gross enrolment ratio (%) in Hungary in 1981?
Your response must be concise. -15.7. What is the difference between the Gross enrolment ratio (%) in Austria in 1976 and the Gross enrolment ratio (%) in China in 1981?
Provide a succinct answer. 33.47. What is the difference between the Gross enrolment ratio (%) in Austria in 1976 and the Gross enrolment ratio (%) in Hungary in 1981?
Provide a short and direct response. -26.68. What is the difference between the Gross enrolment ratio (%) in China in 1976 and the Gross enrolment ratio (%) in Hungary in 1981?
Ensure brevity in your answer.  -66.85. What is the difference between the Gross enrolment ratio (%) in High income: OECD in 1977 and the Gross enrolment ratio (%) in Austria in 1978?
Ensure brevity in your answer.  2.64. What is the difference between the Gross enrolment ratio (%) in High income: OECD in 1977 and the Gross enrolment ratio (%) in China in 1978?
Your answer should be compact. 48.39. What is the difference between the Gross enrolment ratio (%) of High income: OECD in 1977 and the Gross enrolment ratio (%) of Hungary in 1978?
Provide a succinct answer. -4.45. What is the difference between the Gross enrolment ratio (%) in Austria in 1977 and the Gross enrolment ratio (%) in China in 1978?
Your answer should be compact. 40.34. What is the difference between the Gross enrolment ratio (%) of Austria in 1977 and the Gross enrolment ratio (%) of Hungary in 1978?
Make the answer very short. -12.51. What is the difference between the Gross enrolment ratio (%) of China in 1977 and the Gross enrolment ratio (%) of Hungary in 1978?
Offer a terse response. -48.2. What is the difference between the Gross enrolment ratio (%) of High income: OECD in 1977 and the Gross enrolment ratio (%) of Austria in 1979?
Provide a succinct answer. -2.08. What is the difference between the Gross enrolment ratio (%) in High income: OECD in 1977 and the Gross enrolment ratio (%) in China in 1979?
Your answer should be very brief. 49.24. What is the difference between the Gross enrolment ratio (%) of High income: OECD in 1977 and the Gross enrolment ratio (%) of Hungary in 1979?
Provide a succinct answer. -10.19. What is the difference between the Gross enrolment ratio (%) of Austria in 1977 and the Gross enrolment ratio (%) of China in 1979?
Your response must be concise. 41.18. What is the difference between the Gross enrolment ratio (%) in Austria in 1977 and the Gross enrolment ratio (%) in Hungary in 1979?
Your response must be concise. -18.24. What is the difference between the Gross enrolment ratio (%) of China in 1977 and the Gross enrolment ratio (%) of Hungary in 1979?
Your answer should be compact. -53.93. What is the difference between the Gross enrolment ratio (%) in High income: OECD in 1977 and the Gross enrolment ratio (%) in Austria in 1980?
Keep it short and to the point. -5.18. What is the difference between the Gross enrolment ratio (%) of High income: OECD in 1977 and the Gross enrolment ratio (%) of China in 1980?
Ensure brevity in your answer.  47.97. What is the difference between the Gross enrolment ratio (%) in High income: OECD in 1977 and the Gross enrolment ratio (%) in Hungary in 1980?
Ensure brevity in your answer.  -13.75. What is the difference between the Gross enrolment ratio (%) in Austria in 1977 and the Gross enrolment ratio (%) in China in 1980?
Keep it short and to the point. 39.91. What is the difference between the Gross enrolment ratio (%) of Austria in 1977 and the Gross enrolment ratio (%) of Hungary in 1980?
Provide a short and direct response. -21.8. What is the difference between the Gross enrolment ratio (%) in China in 1977 and the Gross enrolment ratio (%) in Hungary in 1980?
Make the answer very short. -57.49. What is the difference between the Gross enrolment ratio (%) in High income: OECD in 1977 and the Gross enrolment ratio (%) in Austria in 1981?
Offer a very short reply. -6.42. What is the difference between the Gross enrolment ratio (%) in High income: OECD in 1977 and the Gross enrolment ratio (%) in China in 1981?
Make the answer very short. 44.61. What is the difference between the Gross enrolment ratio (%) of High income: OECD in 1977 and the Gross enrolment ratio (%) of Hungary in 1981?
Provide a succinct answer. -15.54. What is the difference between the Gross enrolment ratio (%) in Austria in 1977 and the Gross enrolment ratio (%) in China in 1981?
Your answer should be very brief. 36.56. What is the difference between the Gross enrolment ratio (%) in Austria in 1977 and the Gross enrolment ratio (%) in Hungary in 1981?
Offer a terse response. -23.6. What is the difference between the Gross enrolment ratio (%) in China in 1977 and the Gross enrolment ratio (%) in Hungary in 1981?
Ensure brevity in your answer.  -59.29. What is the difference between the Gross enrolment ratio (%) in High income: OECD in 1978 and the Gross enrolment ratio (%) in Austria in 1979?
Give a very brief answer. -2.5. What is the difference between the Gross enrolment ratio (%) in High income: OECD in 1978 and the Gross enrolment ratio (%) in China in 1979?
Provide a succinct answer. 48.82. What is the difference between the Gross enrolment ratio (%) in High income: OECD in 1978 and the Gross enrolment ratio (%) in Hungary in 1979?
Offer a very short reply. -10.61. What is the difference between the Gross enrolment ratio (%) of Austria in 1978 and the Gross enrolment ratio (%) of China in 1979?
Offer a very short reply. 46.59. What is the difference between the Gross enrolment ratio (%) in Austria in 1978 and the Gross enrolment ratio (%) in Hungary in 1979?
Your response must be concise. -12.83. What is the difference between the Gross enrolment ratio (%) of China in 1978 and the Gross enrolment ratio (%) of Hungary in 1979?
Provide a succinct answer. -58.58. What is the difference between the Gross enrolment ratio (%) of High income: OECD in 1978 and the Gross enrolment ratio (%) of Austria in 1980?
Keep it short and to the point. -5.6. What is the difference between the Gross enrolment ratio (%) of High income: OECD in 1978 and the Gross enrolment ratio (%) of China in 1980?
Give a very brief answer. 47.55. What is the difference between the Gross enrolment ratio (%) in High income: OECD in 1978 and the Gross enrolment ratio (%) in Hungary in 1980?
Keep it short and to the point. -14.17. What is the difference between the Gross enrolment ratio (%) of Austria in 1978 and the Gross enrolment ratio (%) of China in 1980?
Your answer should be compact. 45.32. What is the difference between the Gross enrolment ratio (%) of Austria in 1978 and the Gross enrolment ratio (%) of Hungary in 1980?
Your response must be concise. -16.39. What is the difference between the Gross enrolment ratio (%) of China in 1978 and the Gross enrolment ratio (%) of Hungary in 1980?
Your answer should be very brief. -62.14. What is the difference between the Gross enrolment ratio (%) in High income: OECD in 1978 and the Gross enrolment ratio (%) in Austria in 1981?
Provide a succinct answer. -6.84. What is the difference between the Gross enrolment ratio (%) of High income: OECD in 1978 and the Gross enrolment ratio (%) of China in 1981?
Provide a short and direct response. 44.19. What is the difference between the Gross enrolment ratio (%) in High income: OECD in 1978 and the Gross enrolment ratio (%) in Hungary in 1981?
Keep it short and to the point. -15.96. What is the difference between the Gross enrolment ratio (%) of Austria in 1978 and the Gross enrolment ratio (%) of China in 1981?
Your answer should be very brief. 41.97. What is the difference between the Gross enrolment ratio (%) in Austria in 1978 and the Gross enrolment ratio (%) in Hungary in 1981?
Your response must be concise. -18.18. What is the difference between the Gross enrolment ratio (%) of China in 1978 and the Gross enrolment ratio (%) of Hungary in 1981?
Give a very brief answer. -63.93. What is the difference between the Gross enrolment ratio (%) of High income: OECD in 1979 and the Gross enrolment ratio (%) of Austria in 1980?
Provide a short and direct response. -5.37. What is the difference between the Gross enrolment ratio (%) of High income: OECD in 1979 and the Gross enrolment ratio (%) of China in 1980?
Your answer should be compact. 47.78. What is the difference between the Gross enrolment ratio (%) in High income: OECD in 1979 and the Gross enrolment ratio (%) in Hungary in 1980?
Ensure brevity in your answer.  -13.94. What is the difference between the Gross enrolment ratio (%) in Austria in 1979 and the Gross enrolment ratio (%) in China in 1980?
Your answer should be very brief. 50.05. What is the difference between the Gross enrolment ratio (%) of Austria in 1979 and the Gross enrolment ratio (%) of Hungary in 1980?
Make the answer very short. -11.67. What is the difference between the Gross enrolment ratio (%) in China in 1979 and the Gross enrolment ratio (%) in Hungary in 1980?
Provide a short and direct response. -62.99. What is the difference between the Gross enrolment ratio (%) of High income: OECD in 1979 and the Gross enrolment ratio (%) of Austria in 1981?
Your answer should be compact. -6.61. What is the difference between the Gross enrolment ratio (%) in High income: OECD in 1979 and the Gross enrolment ratio (%) in China in 1981?
Give a very brief answer. 44.42. What is the difference between the Gross enrolment ratio (%) in High income: OECD in 1979 and the Gross enrolment ratio (%) in Hungary in 1981?
Provide a succinct answer. -15.73. What is the difference between the Gross enrolment ratio (%) in Austria in 1979 and the Gross enrolment ratio (%) in China in 1981?
Offer a very short reply. 46.69. What is the difference between the Gross enrolment ratio (%) of Austria in 1979 and the Gross enrolment ratio (%) of Hungary in 1981?
Provide a short and direct response. -13.46. What is the difference between the Gross enrolment ratio (%) of China in 1979 and the Gross enrolment ratio (%) of Hungary in 1981?
Provide a short and direct response. -64.78. What is the difference between the Gross enrolment ratio (%) of High income: OECD in 1980 and the Gross enrolment ratio (%) of Austria in 1981?
Your answer should be compact. -5.81. What is the difference between the Gross enrolment ratio (%) of High income: OECD in 1980 and the Gross enrolment ratio (%) of China in 1981?
Your answer should be very brief. 45.22. What is the difference between the Gross enrolment ratio (%) in High income: OECD in 1980 and the Gross enrolment ratio (%) in Hungary in 1981?
Offer a terse response. -14.93. What is the difference between the Gross enrolment ratio (%) of Austria in 1980 and the Gross enrolment ratio (%) of China in 1981?
Your response must be concise. 49.8. What is the difference between the Gross enrolment ratio (%) of Austria in 1980 and the Gross enrolment ratio (%) of Hungary in 1981?
Offer a terse response. -10.36. What is the difference between the Gross enrolment ratio (%) of China in 1980 and the Gross enrolment ratio (%) of Hungary in 1981?
Give a very brief answer. -63.51. What is the average Gross enrolment ratio (%) in High income: OECD per year?
Your answer should be very brief. 56.66. What is the average Gross enrolment ratio (%) of Austria per year?
Ensure brevity in your answer.  52.14. What is the average Gross enrolment ratio (%) in China per year?
Keep it short and to the point. 7.89. What is the average Gross enrolment ratio (%) of Hungary per year?
Your response must be concise. 60.86. In the year 1974, what is the difference between the Gross enrolment ratio (%) in High income: OECD and Gross enrolment ratio (%) in Austria?
Give a very brief answer. 13.49. In the year 1974, what is the difference between the Gross enrolment ratio (%) in High income: OECD and Gross enrolment ratio (%) in China?
Make the answer very short. 50.37. In the year 1974, what is the difference between the Gross enrolment ratio (%) of High income: OECD and Gross enrolment ratio (%) of Hungary?
Your response must be concise. 1.98. In the year 1974, what is the difference between the Gross enrolment ratio (%) in Austria and Gross enrolment ratio (%) in China?
Offer a terse response. 36.87. In the year 1974, what is the difference between the Gross enrolment ratio (%) in Austria and Gross enrolment ratio (%) in Hungary?
Give a very brief answer. -11.51. In the year 1974, what is the difference between the Gross enrolment ratio (%) of China and Gross enrolment ratio (%) of Hungary?
Keep it short and to the point. -48.39. In the year 1975, what is the difference between the Gross enrolment ratio (%) of High income: OECD and Gross enrolment ratio (%) of Austria?
Keep it short and to the point. 12.51. In the year 1975, what is the difference between the Gross enrolment ratio (%) in High income: OECD and Gross enrolment ratio (%) in China?
Ensure brevity in your answer.  52.57. In the year 1975, what is the difference between the Gross enrolment ratio (%) in High income: OECD and Gross enrolment ratio (%) in Hungary?
Offer a terse response. 2.22. In the year 1975, what is the difference between the Gross enrolment ratio (%) in Austria and Gross enrolment ratio (%) in China?
Provide a succinct answer. 40.06. In the year 1975, what is the difference between the Gross enrolment ratio (%) in Austria and Gross enrolment ratio (%) in Hungary?
Offer a very short reply. -10.28. In the year 1975, what is the difference between the Gross enrolment ratio (%) of China and Gross enrolment ratio (%) of Hungary?
Offer a terse response. -50.34. In the year 1976, what is the difference between the Gross enrolment ratio (%) of High income: OECD and Gross enrolment ratio (%) of Austria?
Make the answer very short. 10.98. In the year 1976, what is the difference between the Gross enrolment ratio (%) of High income: OECD and Gross enrolment ratio (%) of China?
Offer a very short reply. 51.15. In the year 1976, what is the difference between the Gross enrolment ratio (%) in High income: OECD and Gross enrolment ratio (%) in Hungary?
Give a very brief answer. 3.16. In the year 1976, what is the difference between the Gross enrolment ratio (%) of Austria and Gross enrolment ratio (%) of China?
Your answer should be compact. 40.17. In the year 1976, what is the difference between the Gross enrolment ratio (%) of Austria and Gross enrolment ratio (%) of Hungary?
Provide a short and direct response. -7.82. In the year 1976, what is the difference between the Gross enrolment ratio (%) in China and Gross enrolment ratio (%) in Hungary?
Your answer should be very brief. -47.99. In the year 1977, what is the difference between the Gross enrolment ratio (%) in High income: OECD and Gross enrolment ratio (%) in Austria?
Provide a short and direct response. 8.05. In the year 1977, what is the difference between the Gross enrolment ratio (%) of High income: OECD and Gross enrolment ratio (%) of China?
Offer a very short reply. 43.74. In the year 1977, what is the difference between the Gross enrolment ratio (%) of High income: OECD and Gross enrolment ratio (%) of Hungary?
Provide a succinct answer. 0.84. In the year 1977, what is the difference between the Gross enrolment ratio (%) of Austria and Gross enrolment ratio (%) of China?
Give a very brief answer. 35.69. In the year 1977, what is the difference between the Gross enrolment ratio (%) of Austria and Gross enrolment ratio (%) of Hungary?
Provide a short and direct response. -7.21. In the year 1977, what is the difference between the Gross enrolment ratio (%) in China and Gross enrolment ratio (%) in Hungary?
Your response must be concise. -42.9. In the year 1978, what is the difference between the Gross enrolment ratio (%) in High income: OECD and Gross enrolment ratio (%) in Austria?
Make the answer very short. 2.22. In the year 1978, what is the difference between the Gross enrolment ratio (%) in High income: OECD and Gross enrolment ratio (%) in China?
Give a very brief answer. 47.97. In the year 1978, what is the difference between the Gross enrolment ratio (%) in High income: OECD and Gross enrolment ratio (%) in Hungary?
Your answer should be compact. -4.87. In the year 1978, what is the difference between the Gross enrolment ratio (%) of Austria and Gross enrolment ratio (%) of China?
Make the answer very short. 45.75. In the year 1978, what is the difference between the Gross enrolment ratio (%) in Austria and Gross enrolment ratio (%) in Hungary?
Provide a succinct answer. -7.09. In the year 1978, what is the difference between the Gross enrolment ratio (%) of China and Gross enrolment ratio (%) of Hungary?
Give a very brief answer. -52.84. In the year 1979, what is the difference between the Gross enrolment ratio (%) of High income: OECD and Gross enrolment ratio (%) of Austria?
Offer a very short reply. -2.27. In the year 1979, what is the difference between the Gross enrolment ratio (%) of High income: OECD and Gross enrolment ratio (%) of China?
Your answer should be compact. 49.05. In the year 1979, what is the difference between the Gross enrolment ratio (%) of High income: OECD and Gross enrolment ratio (%) of Hungary?
Provide a short and direct response. -10.38. In the year 1979, what is the difference between the Gross enrolment ratio (%) of Austria and Gross enrolment ratio (%) of China?
Ensure brevity in your answer.  51.32. In the year 1979, what is the difference between the Gross enrolment ratio (%) in Austria and Gross enrolment ratio (%) in Hungary?
Make the answer very short. -8.11. In the year 1979, what is the difference between the Gross enrolment ratio (%) of China and Gross enrolment ratio (%) of Hungary?
Your response must be concise. -59.43. In the year 1980, what is the difference between the Gross enrolment ratio (%) of High income: OECD and Gross enrolment ratio (%) of Austria?
Your answer should be compact. -4.58. In the year 1980, what is the difference between the Gross enrolment ratio (%) of High income: OECD and Gross enrolment ratio (%) of China?
Your response must be concise. 48.57. In the year 1980, what is the difference between the Gross enrolment ratio (%) in High income: OECD and Gross enrolment ratio (%) in Hungary?
Keep it short and to the point. -13.14. In the year 1980, what is the difference between the Gross enrolment ratio (%) in Austria and Gross enrolment ratio (%) in China?
Provide a succinct answer. 53.15. In the year 1980, what is the difference between the Gross enrolment ratio (%) of Austria and Gross enrolment ratio (%) of Hungary?
Offer a terse response. -8.57. In the year 1980, what is the difference between the Gross enrolment ratio (%) of China and Gross enrolment ratio (%) of Hungary?
Offer a very short reply. -61.72. In the year 1981, what is the difference between the Gross enrolment ratio (%) of High income: OECD and Gross enrolment ratio (%) of Austria?
Keep it short and to the point. -4.24. In the year 1981, what is the difference between the Gross enrolment ratio (%) in High income: OECD and Gross enrolment ratio (%) in China?
Your answer should be very brief. 46.8. In the year 1981, what is the difference between the Gross enrolment ratio (%) of High income: OECD and Gross enrolment ratio (%) of Hungary?
Your response must be concise. -13.36. In the year 1981, what is the difference between the Gross enrolment ratio (%) of Austria and Gross enrolment ratio (%) of China?
Your response must be concise. 51.03. In the year 1981, what is the difference between the Gross enrolment ratio (%) of Austria and Gross enrolment ratio (%) of Hungary?
Your response must be concise. -9.12. In the year 1981, what is the difference between the Gross enrolment ratio (%) in China and Gross enrolment ratio (%) in Hungary?
Offer a terse response. -60.15. What is the ratio of the Gross enrolment ratio (%) of Austria in 1974 to that in 1975?
Your answer should be very brief. 0.92. What is the ratio of the Gross enrolment ratio (%) in China in 1974 to that in 1975?
Make the answer very short. 0.93. What is the ratio of the Gross enrolment ratio (%) in Hungary in 1974 to that in 1975?
Keep it short and to the point. 0.96. What is the ratio of the Gross enrolment ratio (%) in High income: OECD in 1974 to that in 1976?
Keep it short and to the point. 0.92. What is the ratio of the Gross enrolment ratio (%) of Austria in 1974 to that in 1976?
Make the answer very short. 0.85. What is the ratio of the Gross enrolment ratio (%) in China in 1974 to that in 1976?
Give a very brief answer. 0.4. What is the ratio of the Gross enrolment ratio (%) of Hungary in 1974 to that in 1976?
Provide a succinct answer. 0.94. What is the ratio of the Gross enrolment ratio (%) of High income: OECD in 1974 to that in 1977?
Keep it short and to the point. 0.92. What is the ratio of the Gross enrolment ratio (%) of Austria in 1974 to that in 1977?
Offer a terse response. 0.8. What is the ratio of the Gross enrolment ratio (%) of China in 1974 to that in 1977?
Make the answer very short. 0.17. What is the ratio of the Gross enrolment ratio (%) in Hungary in 1974 to that in 1977?
Keep it short and to the point. 0.9. What is the ratio of the Gross enrolment ratio (%) of High income: OECD in 1974 to that in 1978?
Keep it short and to the point. 0.93. What is the ratio of the Gross enrolment ratio (%) of Austria in 1974 to that in 1978?
Provide a short and direct response. 0.72. What is the ratio of the Gross enrolment ratio (%) of China in 1974 to that in 1978?
Give a very brief answer. 0.27. What is the ratio of the Gross enrolment ratio (%) in Hungary in 1974 to that in 1978?
Make the answer very short. 0.82. What is the ratio of the Gross enrolment ratio (%) in High income: OECD in 1974 to that in 1979?
Provide a short and direct response. 0.92. What is the ratio of the Gross enrolment ratio (%) in Austria in 1974 to that in 1979?
Give a very brief answer. 0.66. What is the ratio of the Gross enrolment ratio (%) in China in 1974 to that in 1979?
Your answer should be very brief. 0.29. What is the ratio of the Gross enrolment ratio (%) of Hungary in 1974 to that in 1979?
Provide a succinct answer. 0.75. What is the ratio of the Gross enrolment ratio (%) of High income: OECD in 1974 to that in 1980?
Give a very brief answer. 0.91. What is the ratio of the Gross enrolment ratio (%) in Austria in 1974 to that in 1980?
Your answer should be compact. 0.63. What is the ratio of the Gross enrolment ratio (%) in China in 1974 to that in 1980?
Provide a short and direct response. 0.25. What is the ratio of the Gross enrolment ratio (%) of Hungary in 1974 to that in 1980?
Keep it short and to the point. 0.71. What is the ratio of the Gross enrolment ratio (%) of High income: OECD in 1974 to that in 1981?
Keep it short and to the point. 0.89. What is the ratio of the Gross enrolment ratio (%) of Austria in 1974 to that in 1981?
Provide a succinct answer. 0.62. What is the ratio of the Gross enrolment ratio (%) in China in 1974 to that in 1981?
Make the answer very short. 0.19. What is the ratio of the Gross enrolment ratio (%) of Hungary in 1974 to that in 1981?
Your answer should be compact. 0.7. What is the ratio of the Gross enrolment ratio (%) in High income: OECD in 1975 to that in 1976?
Offer a very short reply. 0.96. What is the ratio of the Gross enrolment ratio (%) of Austria in 1975 to that in 1976?
Make the answer very short. 0.92. What is the ratio of the Gross enrolment ratio (%) in China in 1975 to that in 1976?
Offer a very short reply. 0.42. What is the ratio of the Gross enrolment ratio (%) of Hungary in 1975 to that in 1976?
Offer a very short reply. 0.98. What is the ratio of the Gross enrolment ratio (%) in High income: OECD in 1975 to that in 1977?
Provide a short and direct response. 0.96. What is the ratio of the Gross enrolment ratio (%) of Austria in 1975 to that in 1977?
Make the answer very short. 0.87. What is the ratio of the Gross enrolment ratio (%) of China in 1975 to that in 1977?
Provide a succinct answer. 0.19. What is the ratio of the Gross enrolment ratio (%) in Hungary in 1975 to that in 1977?
Provide a succinct answer. 0.94. What is the ratio of the Gross enrolment ratio (%) of High income: OECD in 1975 to that in 1978?
Your answer should be very brief. 0.97. What is the ratio of the Gross enrolment ratio (%) in Austria in 1975 to that in 1978?
Make the answer very short. 0.78. What is the ratio of the Gross enrolment ratio (%) of China in 1975 to that in 1978?
Provide a succinct answer. 0.28. What is the ratio of the Gross enrolment ratio (%) of Hungary in 1975 to that in 1978?
Provide a succinct answer. 0.86. What is the ratio of the Gross enrolment ratio (%) in High income: OECD in 1975 to that in 1979?
Provide a succinct answer. 0.97. What is the ratio of the Gross enrolment ratio (%) in Austria in 1975 to that in 1979?
Offer a terse response. 0.72. What is the ratio of the Gross enrolment ratio (%) of China in 1975 to that in 1979?
Provide a short and direct response. 0.31. What is the ratio of the Gross enrolment ratio (%) of Hungary in 1975 to that in 1979?
Provide a succinct answer. 0.78. What is the ratio of the Gross enrolment ratio (%) of High income: OECD in 1975 to that in 1980?
Your answer should be very brief. 0.95. What is the ratio of the Gross enrolment ratio (%) in Austria in 1975 to that in 1980?
Offer a very short reply. 0.68. What is the ratio of the Gross enrolment ratio (%) in China in 1975 to that in 1980?
Offer a very short reply. 0.27. What is the ratio of the Gross enrolment ratio (%) of Hungary in 1975 to that in 1980?
Provide a succinct answer. 0.74. What is the ratio of the Gross enrolment ratio (%) of High income: OECD in 1975 to that in 1981?
Give a very brief answer. 0.93. What is the ratio of the Gross enrolment ratio (%) of Austria in 1975 to that in 1981?
Offer a terse response. 0.67. What is the ratio of the Gross enrolment ratio (%) of China in 1975 to that in 1981?
Your answer should be compact. 0.2. What is the ratio of the Gross enrolment ratio (%) of Hungary in 1975 to that in 1981?
Keep it short and to the point. 0.73. What is the ratio of the Gross enrolment ratio (%) in Austria in 1976 to that in 1977?
Provide a succinct answer. 0.94. What is the ratio of the Gross enrolment ratio (%) of China in 1976 to that in 1977?
Offer a very short reply. 0.44. What is the ratio of the Gross enrolment ratio (%) of Hungary in 1976 to that in 1977?
Provide a short and direct response. 0.96. What is the ratio of the Gross enrolment ratio (%) in High income: OECD in 1976 to that in 1978?
Make the answer very short. 1. What is the ratio of the Gross enrolment ratio (%) of Austria in 1976 to that in 1978?
Provide a short and direct response. 0.84. What is the ratio of the Gross enrolment ratio (%) of China in 1976 to that in 1978?
Your response must be concise. 0.67. What is the ratio of the Gross enrolment ratio (%) in Hungary in 1976 to that in 1978?
Keep it short and to the point. 0.87. What is the ratio of the Gross enrolment ratio (%) of High income: OECD in 1976 to that in 1979?
Ensure brevity in your answer.  1. What is the ratio of the Gross enrolment ratio (%) in Austria in 1976 to that in 1979?
Provide a short and direct response. 0.78. What is the ratio of the Gross enrolment ratio (%) in China in 1976 to that in 1979?
Keep it short and to the point. 0.74. What is the ratio of the Gross enrolment ratio (%) of Hungary in 1976 to that in 1979?
Your answer should be very brief. 0.8. What is the ratio of the Gross enrolment ratio (%) of High income: OECD in 1976 to that in 1980?
Give a very brief answer. 0.99. What is the ratio of the Gross enrolment ratio (%) of Austria in 1976 to that in 1980?
Give a very brief answer. 0.74. What is the ratio of the Gross enrolment ratio (%) in China in 1976 to that in 1980?
Your response must be concise. 0.64. What is the ratio of the Gross enrolment ratio (%) of Hungary in 1976 to that in 1980?
Give a very brief answer. 0.76. What is the ratio of the Gross enrolment ratio (%) of High income: OECD in 1976 to that in 1981?
Offer a very short reply. 0.96. What is the ratio of the Gross enrolment ratio (%) of Austria in 1976 to that in 1981?
Your response must be concise. 0.72. What is the ratio of the Gross enrolment ratio (%) in China in 1976 to that in 1981?
Provide a short and direct response. 0.47. What is the ratio of the Gross enrolment ratio (%) of Hungary in 1976 to that in 1981?
Provide a short and direct response. 0.74. What is the ratio of the Gross enrolment ratio (%) of High income: OECD in 1977 to that in 1978?
Provide a succinct answer. 1.01. What is the ratio of the Gross enrolment ratio (%) of Austria in 1977 to that in 1978?
Make the answer very short. 0.9. What is the ratio of the Gross enrolment ratio (%) in China in 1977 to that in 1978?
Your answer should be compact. 1.52. What is the ratio of the Gross enrolment ratio (%) of Hungary in 1977 to that in 1978?
Give a very brief answer. 0.91. What is the ratio of the Gross enrolment ratio (%) in High income: OECD in 1977 to that in 1979?
Ensure brevity in your answer.  1. What is the ratio of the Gross enrolment ratio (%) in Austria in 1977 to that in 1979?
Provide a succinct answer. 0.83. What is the ratio of the Gross enrolment ratio (%) in China in 1977 to that in 1979?
Ensure brevity in your answer.  1.69. What is the ratio of the Gross enrolment ratio (%) of Hungary in 1977 to that in 1979?
Your answer should be very brief. 0.84. What is the ratio of the Gross enrolment ratio (%) in High income: OECD in 1977 to that in 1980?
Your answer should be compact. 0.99. What is the ratio of the Gross enrolment ratio (%) of Austria in 1977 to that in 1980?
Ensure brevity in your answer.  0.79. What is the ratio of the Gross enrolment ratio (%) in China in 1977 to that in 1980?
Offer a very short reply. 1.46. What is the ratio of the Gross enrolment ratio (%) of Hungary in 1977 to that in 1980?
Offer a very short reply. 0.79. What is the ratio of the Gross enrolment ratio (%) of High income: OECD in 1977 to that in 1981?
Keep it short and to the point. 0.96. What is the ratio of the Gross enrolment ratio (%) in Austria in 1977 to that in 1981?
Offer a terse response. 0.77. What is the ratio of the Gross enrolment ratio (%) of China in 1977 to that in 1981?
Your answer should be very brief. 1.07. What is the ratio of the Gross enrolment ratio (%) in Hungary in 1977 to that in 1981?
Provide a succinct answer. 0.77. What is the ratio of the Gross enrolment ratio (%) of Austria in 1978 to that in 1979?
Offer a terse response. 0.92. What is the ratio of the Gross enrolment ratio (%) in China in 1978 to that in 1979?
Provide a succinct answer. 1.11. What is the ratio of the Gross enrolment ratio (%) of Hungary in 1978 to that in 1979?
Make the answer very short. 0.91. What is the ratio of the Gross enrolment ratio (%) of High income: OECD in 1978 to that in 1980?
Provide a short and direct response. 0.98. What is the ratio of the Gross enrolment ratio (%) in Austria in 1978 to that in 1980?
Keep it short and to the point. 0.87. What is the ratio of the Gross enrolment ratio (%) in China in 1978 to that in 1980?
Keep it short and to the point. 0.95. What is the ratio of the Gross enrolment ratio (%) in Hungary in 1978 to that in 1980?
Provide a short and direct response. 0.87. What is the ratio of the Gross enrolment ratio (%) of High income: OECD in 1978 to that in 1981?
Give a very brief answer. 0.96. What is the ratio of the Gross enrolment ratio (%) in Austria in 1978 to that in 1981?
Your answer should be very brief. 0.86. What is the ratio of the Gross enrolment ratio (%) in China in 1978 to that in 1981?
Offer a very short reply. 0.7. What is the ratio of the Gross enrolment ratio (%) in Hungary in 1978 to that in 1981?
Provide a succinct answer. 0.85. What is the ratio of the Gross enrolment ratio (%) in High income: OECD in 1979 to that in 1980?
Your answer should be compact. 0.99. What is the ratio of the Gross enrolment ratio (%) in Austria in 1979 to that in 1980?
Ensure brevity in your answer.  0.95. What is the ratio of the Gross enrolment ratio (%) in China in 1979 to that in 1980?
Your answer should be very brief. 0.86. What is the ratio of the Gross enrolment ratio (%) of Hungary in 1979 to that in 1980?
Your answer should be very brief. 0.95. What is the ratio of the Gross enrolment ratio (%) in High income: OECD in 1979 to that in 1981?
Your answer should be very brief. 0.96. What is the ratio of the Gross enrolment ratio (%) of Austria in 1979 to that in 1981?
Offer a terse response. 0.93. What is the ratio of the Gross enrolment ratio (%) of China in 1979 to that in 1981?
Provide a succinct answer. 0.63. What is the ratio of the Gross enrolment ratio (%) in Hungary in 1979 to that in 1981?
Ensure brevity in your answer.  0.93. What is the ratio of the Gross enrolment ratio (%) in High income: OECD in 1980 to that in 1981?
Provide a short and direct response. 0.97. What is the ratio of the Gross enrolment ratio (%) in Austria in 1980 to that in 1981?
Make the answer very short. 0.98. What is the ratio of the Gross enrolment ratio (%) in China in 1980 to that in 1981?
Keep it short and to the point. 0.73. What is the ratio of the Gross enrolment ratio (%) of Hungary in 1980 to that in 1981?
Offer a very short reply. 0.98. What is the difference between the highest and the second highest Gross enrolment ratio (%) of High income: OECD?
Your answer should be compact. 1.58. What is the difference between the highest and the second highest Gross enrolment ratio (%) in Austria?
Offer a very short reply. 1.24. What is the difference between the highest and the second highest Gross enrolment ratio (%) in China?
Make the answer very short. 0.87. What is the difference between the highest and the second highest Gross enrolment ratio (%) in Hungary?
Your answer should be compact. 1.79. What is the difference between the highest and the lowest Gross enrolment ratio (%) of High income: OECD?
Give a very brief answer. 6.72. What is the difference between the highest and the lowest Gross enrolment ratio (%) of Austria?
Offer a very short reply. 24.45. What is the difference between the highest and the lowest Gross enrolment ratio (%) in China?
Keep it short and to the point. 11.15. What is the difference between the highest and the lowest Gross enrolment ratio (%) of Hungary?
Offer a terse response. 22.05. 